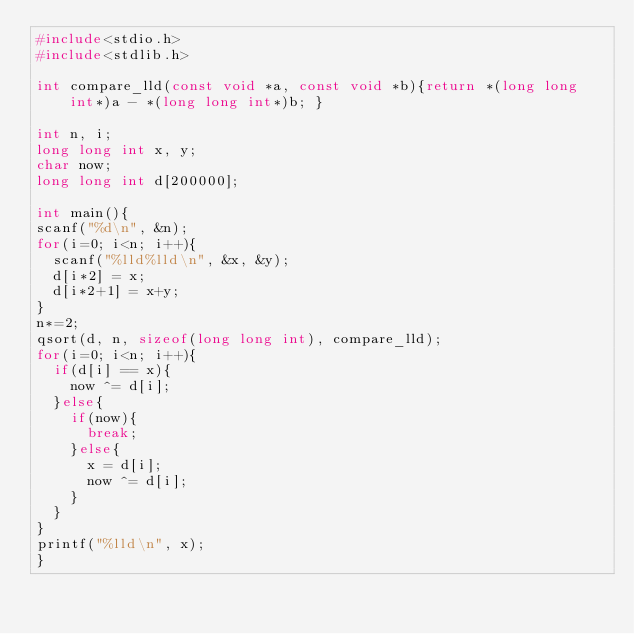<code> <loc_0><loc_0><loc_500><loc_500><_C_>#include<stdio.h>
#include<stdlib.h>

int compare_lld(const void *a, const void *b){return *(long long int*)a - *(long long int*)b; } 

int n, i;
long long int x, y;
char now;
long long int d[200000];

int main(){
scanf("%d\n", &n);
for(i=0; i<n; i++){
  scanf("%lld%lld\n", &x, &y);
  d[i*2] = x;
  d[i*2+1] = x+y;
}
n*=2;
qsort(d, n, sizeof(long long int), compare_lld);
for(i=0; i<n; i++){
  if(d[i] == x){
    now ^= d[i];
  }else{
    if(now){
      break;
    }else{
      x = d[i];
      now ^= d[i];
    }
  }
}
printf("%lld\n", x);
}
</code> 